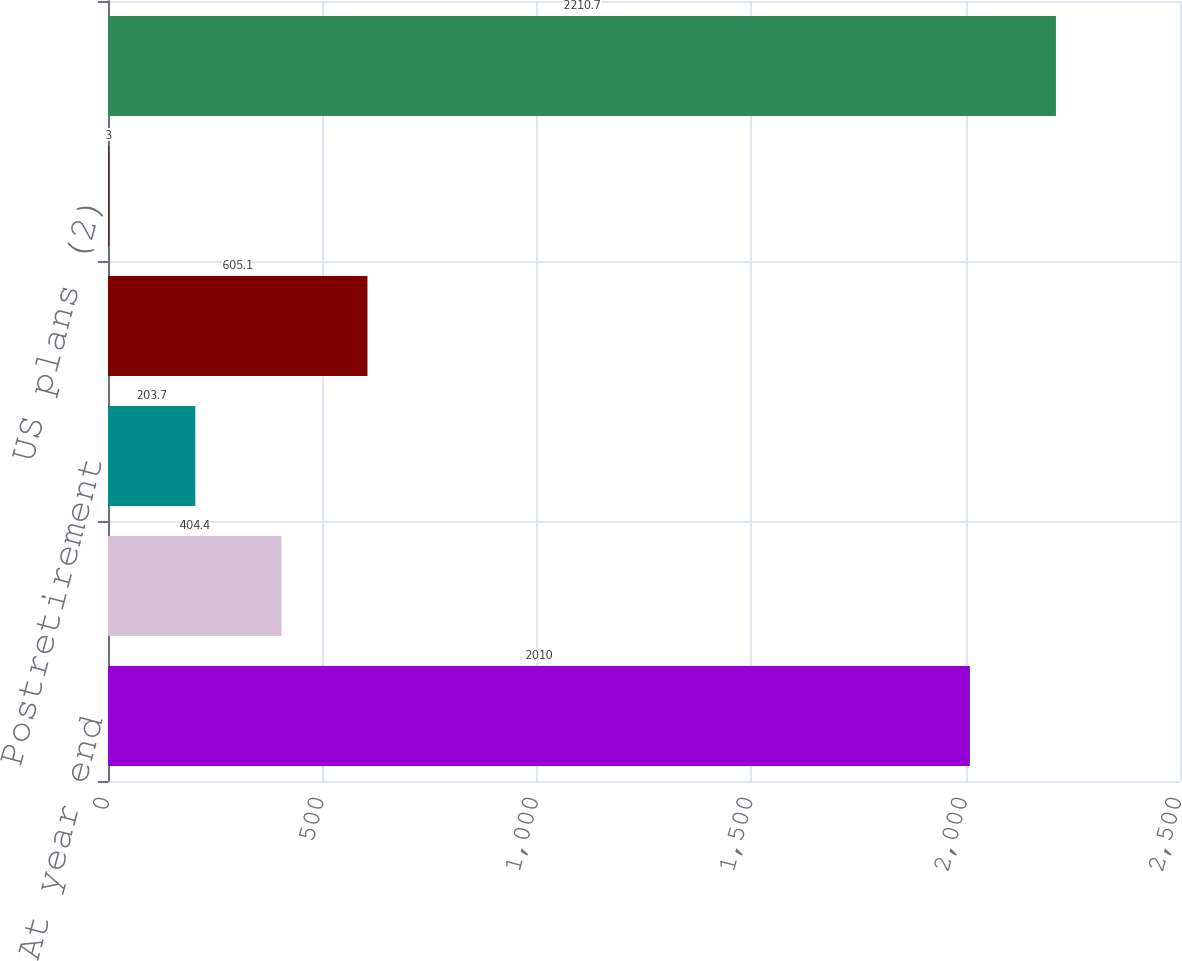Convert chart to OTSL. <chart><loc_0><loc_0><loc_500><loc_500><bar_chart><fcel>At year end<fcel>Pension<fcel>Postretirement<fcel>Weighted average<fcel>US plans (2)<fcel>During the year<nl><fcel>2010<fcel>404.4<fcel>203.7<fcel>605.1<fcel>3<fcel>2210.7<nl></chart> 